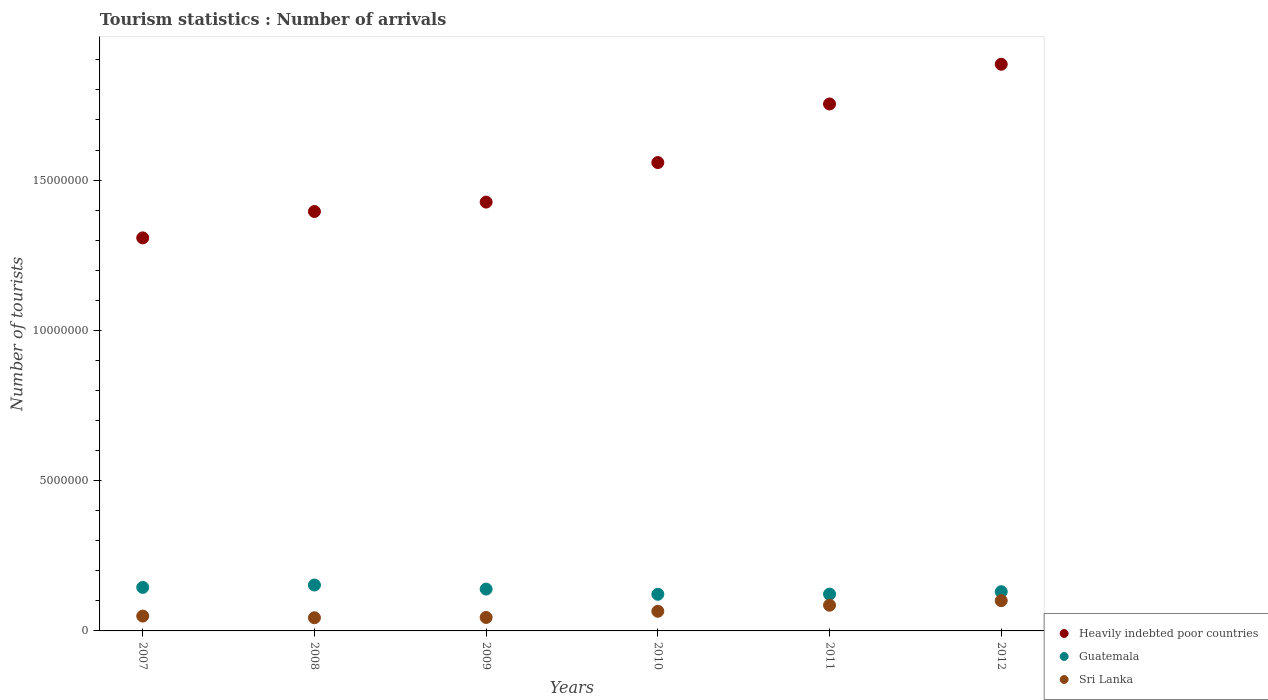How many different coloured dotlines are there?
Provide a succinct answer. 3. What is the number of tourist arrivals in Heavily indebted poor countries in 2007?
Offer a very short reply. 1.31e+07. Across all years, what is the maximum number of tourist arrivals in Heavily indebted poor countries?
Keep it short and to the point. 1.89e+07. Across all years, what is the minimum number of tourist arrivals in Guatemala?
Keep it short and to the point. 1.22e+06. What is the total number of tourist arrivals in Guatemala in the graph?
Provide a succinct answer. 8.12e+06. What is the difference between the number of tourist arrivals in Heavily indebted poor countries in 2007 and that in 2011?
Give a very brief answer. -4.46e+06. What is the difference between the number of tourist arrivals in Heavily indebted poor countries in 2008 and the number of tourist arrivals in Sri Lanka in 2007?
Provide a succinct answer. 1.35e+07. What is the average number of tourist arrivals in Heavily indebted poor countries per year?
Offer a very short reply. 1.55e+07. In the year 2012, what is the difference between the number of tourist arrivals in Sri Lanka and number of tourist arrivals in Guatemala?
Provide a short and direct response. -2.99e+05. In how many years, is the number of tourist arrivals in Guatemala greater than 4000000?
Offer a very short reply. 0. What is the ratio of the number of tourist arrivals in Guatemala in 2009 to that in 2010?
Keep it short and to the point. 1.14. Is the difference between the number of tourist arrivals in Sri Lanka in 2007 and 2011 greater than the difference between the number of tourist arrivals in Guatemala in 2007 and 2011?
Ensure brevity in your answer.  No. What is the difference between the highest and the second highest number of tourist arrivals in Sri Lanka?
Keep it short and to the point. 1.50e+05. What is the difference between the highest and the lowest number of tourist arrivals in Sri Lanka?
Give a very brief answer. 5.68e+05. Is the sum of the number of tourist arrivals in Sri Lanka in 2008 and 2012 greater than the maximum number of tourist arrivals in Guatemala across all years?
Provide a succinct answer. No. Is the number of tourist arrivals in Sri Lanka strictly less than the number of tourist arrivals in Guatemala over the years?
Offer a very short reply. Yes. How many dotlines are there?
Offer a terse response. 3. How many years are there in the graph?
Keep it short and to the point. 6. What is the difference between two consecutive major ticks on the Y-axis?
Provide a short and direct response. 5.00e+06. Where does the legend appear in the graph?
Offer a very short reply. Bottom right. How many legend labels are there?
Offer a terse response. 3. What is the title of the graph?
Ensure brevity in your answer.  Tourism statistics : Number of arrivals. Does "Spain" appear as one of the legend labels in the graph?
Provide a succinct answer. No. What is the label or title of the X-axis?
Offer a terse response. Years. What is the label or title of the Y-axis?
Offer a very short reply. Number of tourists. What is the Number of tourists in Heavily indebted poor countries in 2007?
Your answer should be compact. 1.31e+07. What is the Number of tourists of Guatemala in 2007?
Provide a short and direct response. 1.45e+06. What is the Number of tourists in Sri Lanka in 2007?
Your response must be concise. 4.94e+05. What is the Number of tourists in Heavily indebted poor countries in 2008?
Make the answer very short. 1.40e+07. What is the Number of tourists of Guatemala in 2008?
Your answer should be compact. 1.53e+06. What is the Number of tourists of Sri Lanka in 2008?
Give a very brief answer. 4.38e+05. What is the Number of tourists of Heavily indebted poor countries in 2009?
Keep it short and to the point. 1.43e+07. What is the Number of tourists of Guatemala in 2009?
Give a very brief answer. 1.39e+06. What is the Number of tourists of Sri Lanka in 2009?
Make the answer very short. 4.48e+05. What is the Number of tourists of Heavily indebted poor countries in 2010?
Ensure brevity in your answer.  1.56e+07. What is the Number of tourists in Guatemala in 2010?
Keep it short and to the point. 1.22e+06. What is the Number of tourists in Sri Lanka in 2010?
Your answer should be compact. 6.54e+05. What is the Number of tourists in Heavily indebted poor countries in 2011?
Your response must be concise. 1.75e+07. What is the Number of tourists of Guatemala in 2011?
Your answer should be compact. 1.22e+06. What is the Number of tourists in Sri Lanka in 2011?
Offer a very short reply. 8.56e+05. What is the Number of tourists in Heavily indebted poor countries in 2012?
Your answer should be very brief. 1.89e+07. What is the Number of tourists in Guatemala in 2012?
Your answer should be compact. 1.30e+06. What is the Number of tourists of Sri Lanka in 2012?
Provide a succinct answer. 1.01e+06. Across all years, what is the maximum Number of tourists of Heavily indebted poor countries?
Give a very brief answer. 1.89e+07. Across all years, what is the maximum Number of tourists of Guatemala?
Offer a very short reply. 1.53e+06. Across all years, what is the maximum Number of tourists of Sri Lanka?
Your response must be concise. 1.01e+06. Across all years, what is the minimum Number of tourists in Heavily indebted poor countries?
Provide a succinct answer. 1.31e+07. Across all years, what is the minimum Number of tourists of Guatemala?
Provide a short and direct response. 1.22e+06. Across all years, what is the minimum Number of tourists in Sri Lanka?
Offer a very short reply. 4.38e+05. What is the total Number of tourists in Heavily indebted poor countries in the graph?
Offer a very short reply. 9.33e+07. What is the total Number of tourists in Guatemala in the graph?
Keep it short and to the point. 8.12e+06. What is the total Number of tourists in Sri Lanka in the graph?
Provide a short and direct response. 3.90e+06. What is the difference between the Number of tourists in Heavily indebted poor countries in 2007 and that in 2008?
Your answer should be compact. -8.78e+05. What is the difference between the Number of tourists of Guatemala in 2007 and that in 2008?
Keep it short and to the point. -7.90e+04. What is the difference between the Number of tourists of Sri Lanka in 2007 and that in 2008?
Offer a very short reply. 5.60e+04. What is the difference between the Number of tourists of Heavily indebted poor countries in 2007 and that in 2009?
Ensure brevity in your answer.  -1.19e+06. What is the difference between the Number of tourists in Guatemala in 2007 and that in 2009?
Offer a terse response. 5.60e+04. What is the difference between the Number of tourists of Sri Lanka in 2007 and that in 2009?
Keep it short and to the point. 4.60e+04. What is the difference between the Number of tourists of Heavily indebted poor countries in 2007 and that in 2010?
Ensure brevity in your answer.  -2.51e+06. What is the difference between the Number of tourists of Guatemala in 2007 and that in 2010?
Offer a very short reply. 2.29e+05. What is the difference between the Number of tourists in Sri Lanka in 2007 and that in 2010?
Your answer should be very brief. -1.60e+05. What is the difference between the Number of tourists in Heavily indebted poor countries in 2007 and that in 2011?
Your answer should be very brief. -4.46e+06. What is the difference between the Number of tourists in Guatemala in 2007 and that in 2011?
Your answer should be very brief. 2.23e+05. What is the difference between the Number of tourists of Sri Lanka in 2007 and that in 2011?
Your response must be concise. -3.62e+05. What is the difference between the Number of tourists of Heavily indebted poor countries in 2007 and that in 2012?
Make the answer very short. -5.78e+06. What is the difference between the Number of tourists of Guatemala in 2007 and that in 2012?
Your answer should be compact. 1.43e+05. What is the difference between the Number of tourists in Sri Lanka in 2007 and that in 2012?
Provide a succinct answer. -5.12e+05. What is the difference between the Number of tourists of Heavily indebted poor countries in 2008 and that in 2009?
Keep it short and to the point. -3.13e+05. What is the difference between the Number of tourists in Guatemala in 2008 and that in 2009?
Your response must be concise. 1.35e+05. What is the difference between the Number of tourists of Heavily indebted poor countries in 2008 and that in 2010?
Make the answer very short. -1.63e+06. What is the difference between the Number of tourists of Guatemala in 2008 and that in 2010?
Provide a succinct answer. 3.08e+05. What is the difference between the Number of tourists in Sri Lanka in 2008 and that in 2010?
Your answer should be very brief. -2.16e+05. What is the difference between the Number of tourists of Heavily indebted poor countries in 2008 and that in 2011?
Your answer should be very brief. -3.58e+06. What is the difference between the Number of tourists of Guatemala in 2008 and that in 2011?
Your answer should be very brief. 3.02e+05. What is the difference between the Number of tourists in Sri Lanka in 2008 and that in 2011?
Give a very brief answer. -4.18e+05. What is the difference between the Number of tourists of Heavily indebted poor countries in 2008 and that in 2012?
Offer a very short reply. -4.90e+06. What is the difference between the Number of tourists in Guatemala in 2008 and that in 2012?
Offer a very short reply. 2.22e+05. What is the difference between the Number of tourists of Sri Lanka in 2008 and that in 2012?
Give a very brief answer. -5.68e+05. What is the difference between the Number of tourists in Heavily indebted poor countries in 2009 and that in 2010?
Provide a short and direct response. -1.32e+06. What is the difference between the Number of tourists of Guatemala in 2009 and that in 2010?
Give a very brief answer. 1.73e+05. What is the difference between the Number of tourists in Sri Lanka in 2009 and that in 2010?
Your answer should be very brief. -2.06e+05. What is the difference between the Number of tourists of Heavily indebted poor countries in 2009 and that in 2011?
Offer a terse response. -3.26e+06. What is the difference between the Number of tourists in Guatemala in 2009 and that in 2011?
Your answer should be compact. 1.67e+05. What is the difference between the Number of tourists in Sri Lanka in 2009 and that in 2011?
Ensure brevity in your answer.  -4.08e+05. What is the difference between the Number of tourists of Heavily indebted poor countries in 2009 and that in 2012?
Make the answer very short. -4.59e+06. What is the difference between the Number of tourists of Guatemala in 2009 and that in 2012?
Provide a succinct answer. 8.70e+04. What is the difference between the Number of tourists in Sri Lanka in 2009 and that in 2012?
Your answer should be very brief. -5.58e+05. What is the difference between the Number of tourists of Heavily indebted poor countries in 2010 and that in 2011?
Keep it short and to the point. -1.95e+06. What is the difference between the Number of tourists in Guatemala in 2010 and that in 2011?
Offer a terse response. -6000. What is the difference between the Number of tourists in Sri Lanka in 2010 and that in 2011?
Keep it short and to the point. -2.02e+05. What is the difference between the Number of tourists in Heavily indebted poor countries in 2010 and that in 2012?
Provide a short and direct response. -3.27e+06. What is the difference between the Number of tourists in Guatemala in 2010 and that in 2012?
Keep it short and to the point. -8.60e+04. What is the difference between the Number of tourists in Sri Lanka in 2010 and that in 2012?
Your answer should be very brief. -3.52e+05. What is the difference between the Number of tourists of Heavily indebted poor countries in 2011 and that in 2012?
Give a very brief answer. -1.32e+06. What is the difference between the Number of tourists in Heavily indebted poor countries in 2007 and the Number of tourists in Guatemala in 2008?
Make the answer very short. 1.16e+07. What is the difference between the Number of tourists in Heavily indebted poor countries in 2007 and the Number of tourists in Sri Lanka in 2008?
Offer a terse response. 1.26e+07. What is the difference between the Number of tourists of Guatemala in 2007 and the Number of tourists of Sri Lanka in 2008?
Offer a terse response. 1.01e+06. What is the difference between the Number of tourists in Heavily indebted poor countries in 2007 and the Number of tourists in Guatemala in 2009?
Give a very brief answer. 1.17e+07. What is the difference between the Number of tourists of Heavily indebted poor countries in 2007 and the Number of tourists of Sri Lanka in 2009?
Your answer should be very brief. 1.26e+07. What is the difference between the Number of tourists in Guatemala in 2007 and the Number of tourists in Sri Lanka in 2009?
Provide a short and direct response. 1.00e+06. What is the difference between the Number of tourists in Heavily indebted poor countries in 2007 and the Number of tourists in Guatemala in 2010?
Offer a very short reply. 1.19e+07. What is the difference between the Number of tourists in Heavily indebted poor countries in 2007 and the Number of tourists in Sri Lanka in 2010?
Your answer should be very brief. 1.24e+07. What is the difference between the Number of tourists in Guatemala in 2007 and the Number of tourists in Sri Lanka in 2010?
Offer a very short reply. 7.94e+05. What is the difference between the Number of tourists of Heavily indebted poor countries in 2007 and the Number of tourists of Guatemala in 2011?
Give a very brief answer. 1.19e+07. What is the difference between the Number of tourists of Heavily indebted poor countries in 2007 and the Number of tourists of Sri Lanka in 2011?
Keep it short and to the point. 1.22e+07. What is the difference between the Number of tourists of Guatemala in 2007 and the Number of tourists of Sri Lanka in 2011?
Give a very brief answer. 5.92e+05. What is the difference between the Number of tourists in Heavily indebted poor countries in 2007 and the Number of tourists in Guatemala in 2012?
Ensure brevity in your answer.  1.18e+07. What is the difference between the Number of tourists of Heavily indebted poor countries in 2007 and the Number of tourists of Sri Lanka in 2012?
Give a very brief answer. 1.21e+07. What is the difference between the Number of tourists of Guatemala in 2007 and the Number of tourists of Sri Lanka in 2012?
Your answer should be compact. 4.42e+05. What is the difference between the Number of tourists of Heavily indebted poor countries in 2008 and the Number of tourists of Guatemala in 2009?
Your answer should be compact. 1.26e+07. What is the difference between the Number of tourists in Heavily indebted poor countries in 2008 and the Number of tourists in Sri Lanka in 2009?
Make the answer very short. 1.35e+07. What is the difference between the Number of tourists of Guatemala in 2008 and the Number of tourists of Sri Lanka in 2009?
Your answer should be very brief. 1.08e+06. What is the difference between the Number of tourists in Heavily indebted poor countries in 2008 and the Number of tourists in Guatemala in 2010?
Your answer should be compact. 1.27e+07. What is the difference between the Number of tourists in Heavily indebted poor countries in 2008 and the Number of tourists in Sri Lanka in 2010?
Make the answer very short. 1.33e+07. What is the difference between the Number of tourists in Guatemala in 2008 and the Number of tourists in Sri Lanka in 2010?
Make the answer very short. 8.73e+05. What is the difference between the Number of tourists of Heavily indebted poor countries in 2008 and the Number of tourists of Guatemala in 2011?
Your answer should be compact. 1.27e+07. What is the difference between the Number of tourists of Heavily indebted poor countries in 2008 and the Number of tourists of Sri Lanka in 2011?
Offer a terse response. 1.31e+07. What is the difference between the Number of tourists of Guatemala in 2008 and the Number of tourists of Sri Lanka in 2011?
Make the answer very short. 6.71e+05. What is the difference between the Number of tourists in Heavily indebted poor countries in 2008 and the Number of tourists in Guatemala in 2012?
Your answer should be compact. 1.27e+07. What is the difference between the Number of tourists in Heavily indebted poor countries in 2008 and the Number of tourists in Sri Lanka in 2012?
Offer a terse response. 1.29e+07. What is the difference between the Number of tourists of Guatemala in 2008 and the Number of tourists of Sri Lanka in 2012?
Ensure brevity in your answer.  5.21e+05. What is the difference between the Number of tourists in Heavily indebted poor countries in 2009 and the Number of tourists in Guatemala in 2010?
Give a very brief answer. 1.30e+07. What is the difference between the Number of tourists of Heavily indebted poor countries in 2009 and the Number of tourists of Sri Lanka in 2010?
Give a very brief answer. 1.36e+07. What is the difference between the Number of tourists of Guatemala in 2009 and the Number of tourists of Sri Lanka in 2010?
Offer a very short reply. 7.38e+05. What is the difference between the Number of tourists of Heavily indebted poor countries in 2009 and the Number of tourists of Guatemala in 2011?
Give a very brief answer. 1.30e+07. What is the difference between the Number of tourists of Heavily indebted poor countries in 2009 and the Number of tourists of Sri Lanka in 2011?
Give a very brief answer. 1.34e+07. What is the difference between the Number of tourists in Guatemala in 2009 and the Number of tourists in Sri Lanka in 2011?
Make the answer very short. 5.36e+05. What is the difference between the Number of tourists of Heavily indebted poor countries in 2009 and the Number of tourists of Guatemala in 2012?
Give a very brief answer. 1.30e+07. What is the difference between the Number of tourists in Heavily indebted poor countries in 2009 and the Number of tourists in Sri Lanka in 2012?
Your answer should be very brief. 1.33e+07. What is the difference between the Number of tourists of Guatemala in 2009 and the Number of tourists of Sri Lanka in 2012?
Your answer should be very brief. 3.86e+05. What is the difference between the Number of tourists of Heavily indebted poor countries in 2010 and the Number of tourists of Guatemala in 2011?
Provide a short and direct response. 1.44e+07. What is the difference between the Number of tourists of Heavily indebted poor countries in 2010 and the Number of tourists of Sri Lanka in 2011?
Keep it short and to the point. 1.47e+07. What is the difference between the Number of tourists in Guatemala in 2010 and the Number of tourists in Sri Lanka in 2011?
Ensure brevity in your answer.  3.63e+05. What is the difference between the Number of tourists in Heavily indebted poor countries in 2010 and the Number of tourists in Guatemala in 2012?
Your answer should be very brief. 1.43e+07. What is the difference between the Number of tourists of Heavily indebted poor countries in 2010 and the Number of tourists of Sri Lanka in 2012?
Make the answer very short. 1.46e+07. What is the difference between the Number of tourists in Guatemala in 2010 and the Number of tourists in Sri Lanka in 2012?
Your response must be concise. 2.13e+05. What is the difference between the Number of tourists in Heavily indebted poor countries in 2011 and the Number of tourists in Guatemala in 2012?
Offer a very short reply. 1.62e+07. What is the difference between the Number of tourists of Heavily indebted poor countries in 2011 and the Number of tourists of Sri Lanka in 2012?
Ensure brevity in your answer.  1.65e+07. What is the difference between the Number of tourists in Guatemala in 2011 and the Number of tourists in Sri Lanka in 2012?
Give a very brief answer. 2.19e+05. What is the average Number of tourists of Heavily indebted poor countries per year?
Provide a succinct answer. 1.55e+07. What is the average Number of tourists in Guatemala per year?
Your answer should be compact. 1.35e+06. What is the average Number of tourists in Sri Lanka per year?
Keep it short and to the point. 6.49e+05. In the year 2007, what is the difference between the Number of tourists of Heavily indebted poor countries and Number of tourists of Guatemala?
Give a very brief answer. 1.16e+07. In the year 2007, what is the difference between the Number of tourists of Heavily indebted poor countries and Number of tourists of Sri Lanka?
Make the answer very short. 1.26e+07. In the year 2007, what is the difference between the Number of tourists of Guatemala and Number of tourists of Sri Lanka?
Provide a succinct answer. 9.54e+05. In the year 2008, what is the difference between the Number of tourists of Heavily indebted poor countries and Number of tourists of Guatemala?
Your response must be concise. 1.24e+07. In the year 2008, what is the difference between the Number of tourists of Heavily indebted poor countries and Number of tourists of Sri Lanka?
Ensure brevity in your answer.  1.35e+07. In the year 2008, what is the difference between the Number of tourists of Guatemala and Number of tourists of Sri Lanka?
Make the answer very short. 1.09e+06. In the year 2009, what is the difference between the Number of tourists of Heavily indebted poor countries and Number of tourists of Guatemala?
Your answer should be very brief. 1.29e+07. In the year 2009, what is the difference between the Number of tourists in Heavily indebted poor countries and Number of tourists in Sri Lanka?
Make the answer very short. 1.38e+07. In the year 2009, what is the difference between the Number of tourists of Guatemala and Number of tourists of Sri Lanka?
Your answer should be compact. 9.44e+05. In the year 2010, what is the difference between the Number of tourists of Heavily indebted poor countries and Number of tourists of Guatemala?
Offer a terse response. 1.44e+07. In the year 2010, what is the difference between the Number of tourists in Heavily indebted poor countries and Number of tourists in Sri Lanka?
Your answer should be very brief. 1.49e+07. In the year 2010, what is the difference between the Number of tourists in Guatemala and Number of tourists in Sri Lanka?
Keep it short and to the point. 5.65e+05. In the year 2011, what is the difference between the Number of tourists in Heavily indebted poor countries and Number of tourists in Guatemala?
Offer a terse response. 1.63e+07. In the year 2011, what is the difference between the Number of tourists in Heavily indebted poor countries and Number of tourists in Sri Lanka?
Your response must be concise. 1.67e+07. In the year 2011, what is the difference between the Number of tourists in Guatemala and Number of tourists in Sri Lanka?
Provide a succinct answer. 3.69e+05. In the year 2012, what is the difference between the Number of tourists in Heavily indebted poor countries and Number of tourists in Guatemala?
Give a very brief answer. 1.75e+07. In the year 2012, what is the difference between the Number of tourists of Heavily indebted poor countries and Number of tourists of Sri Lanka?
Your answer should be very brief. 1.78e+07. In the year 2012, what is the difference between the Number of tourists in Guatemala and Number of tourists in Sri Lanka?
Offer a very short reply. 2.99e+05. What is the ratio of the Number of tourists of Heavily indebted poor countries in 2007 to that in 2008?
Provide a short and direct response. 0.94. What is the ratio of the Number of tourists in Guatemala in 2007 to that in 2008?
Offer a very short reply. 0.95. What is the ratio of the Number of tourists in Sri Lanka in 2007 to that in 2008?
Offer a terse response. 1.13. What is the ratio of the Number of tourists of Heavily indebted poor countries in 2007 to that in 2009?
Ensure brevity in your answer.  0.92. What is the ratio of the Number of tourists in Guatemala in 2007 to that in 2009?
Your answer should be compact. 1.04. What is the ratio of the Number of tourists of Sri Lanka in 2007 to that in 2009?
Offer a terse response. 1.1. What is the ratio of the Number of tourists in Heavily indebted poor countries in 2007 to that in 2010?
Provide a short and direct response. 0.84. What is the ratio of the Number of tourists of Guatemala in 2007 to that in 2010?
Ensure brevity in your answer.  1.19. What is the ratio of the Number of tourists of Sri Lanka in 2007 to that in 2010?
Your answer should be compact. 0.76. What is the ratio of the Number of tourists in Heavily indebted poor countries in 2007 to that in 2011?
Make the answer very short. 0.75. What is the ratio of the Number of tourists of Guatemala in 2007 to that in 2011?
Offer a terse response. 1.18. What is the ratio of the Number of tourists in Sri Lanka in 2007 to that in 2011?
Make the answer very short. 0.58. What is the ratio of the Number of tourists of Heavily indebted poor countries in 2007 to that in 2012?
Your answer should be very brief. 0.69. What is the ratio of the Number of tourists of Guatemala in 2007 to that in 2012?
Your answer should be compact. 1.11. What is the ratio of the Number of tourists in Sri Lanka in 2007 to that in 2012?
Keep it short and to the point. 0.49. What is the ratio of the Number of tourists of Heavily indebted poor countries in 2008 to that in 2009?
Provide a short and direct response. 0.98. What is the ratio of the Number of tourists of Guatemala in 2008 to that in 2009?
Offer a very short reply. 1.1. What is the ratio of the Number of tourists of Sri Lanka in 2008 to that in 2009?
Offer a very short reply. 0.98. What is the ratio of the Number of tourists of Heavily indebted poor countries in 2008 to that in 2010?
Your answer should be compact. 0.9. What is the ratio of the Number of tourists in Guatemala in 2008 to that in 2010?
Provide a succinct answer. 1.25. What is the ratio of the Number of tourists in Sri Lanka in 2008 to that in 2010?
Ensure brevity in your answer.  0.67. What is the ratio of the Number of tourists in Heavily indebted poor countries in 2008 to that in 2011?
Offer a terse response. 0.8. What is the ratio of the Number of tourists of Guatemala in 2008 to that in 2011?
Your response must be concise. 1.25. What is the ratio of the Number of tourists in Sri Lanka in 2008 to that in 2011?
Give a very brief answer. 0.51. What is the ratio of the Number of tourists in Heavily indebted poor countries in 2008 to that in 2012?
Make the answer very short. 0.74. What is the ratio of the Number of tourists in Guatemala in 2008 to that in 2012?
Your answer should be compact. 1.17. What is the ratio of the Number of tourists in Sri Lanka in 2008 to that in 2012?
Provide a short and direct response. 0.44. What is the ratio of the Number of tourists of Heavily indebted poor countries in 2009 to that in 2010?
Provide a short and direct response. 0.92. What is the ratio of the Number of tourists of Guatemala in 2009 to that in 2010?
Offer a terse response. 1.14. What is the ratio of the Number of tourists of Sri Lanka in 2009 to that in 2010?
Provide a short and direct response. 0.69. What is the ratio of the Number of tourists in Heavily indebted poor countries in 2009 to that in 2011?
Your answer should be very brief. 0.81. What is the ratio of the Number of tourists in Guatemala in 2009 to that in 2011?
Your answer should be very brief. 1.14. What is the ratio of the Number of tourists of Sri Lanka in 2009 to that in 2011?
Your answer should be compact. 0.52. What is the ratio of the Number of tourists of Heavily indebted poor countries in 2009 to that in 2012?
Provide a short and direct response. 0.76. What is the ratio of the Number of tourists of Guatemala in 2009 to that in 2012?
Provide a short and direct response. 1.07. What is the ratio of the Number of tourists in Sri Lanka in 2009 to that in 2012?
Provide a succinct answer. 0.45. What is the ratio of the Number of tourists in Heavily indebted poor countries in 2010 to that in 2011?
Keep it short and to the point. 0.89. What is the ratio of the Number of tourists of Sri Lanka in 2010 to that in 2011?
Give a very brief answer. 0.76. What is the ratio of the Number of tourists of Heavily indebted poor countries in 2010 to that in 2012?
Provide a short and direct response. 0.83. What is the ratio of the Number of tourists of Guatemala in 2010 to that in 2012?
Ensure brevity in your answer.  0.93. What is the ratio of the Number of tourists in Sri Lanka in 2010 to that in 2012?
Your answer should be compact. 0.65. What is the ratio of the Number of tourists in Heavily indebted poor countries in 2011 to that in 2012?
Keep it short and to the point. 0.93. What is the ratio of the Number of tourists of Guatemala in 2011 to that in 2012?
Make the answer very short. 0.94. What is the ratio of the Number of tourists in Sri Lanka in 2011 to that in 2012?
Make the answer very short. 0.85. What is the difference between the highest and the second highest Number of tourists of Heavily indebted poor countries?
Your response must be concise. 1.32e+06. What is the difference between the highest and the second highest Number of tourists of Guatemala?
Give a very brief answer. 7.90e+04. What is the difference between the highest and the lowest Number of tourists of Heavily indebted poor countries?
Give a very brief answer. 5.78e+06. What is the difference between the highest and the lowest Number of tourists in Guatemala?
Ensure brevity in your answer.  3.08e+05. What is the difference between the highest and the lowest Number of tourists in Sri Lanka?
Provide a succinct answer. 5.68e+05. 